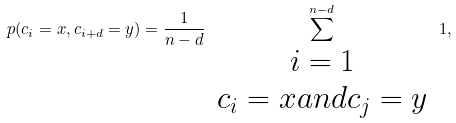Convert formula to latex. <formula><loc_0><loc_0><loc_500><loc_500>p ( c _ { i } = x , c _ { i + d } = y ) = \frac { 1 } { n - d } \sum _ { \begin{array} { c } i = 1 \\ c _ { i } = x a n d c _ { j } = y \end{array} } ^ { n - d } 1 ,</formula> 